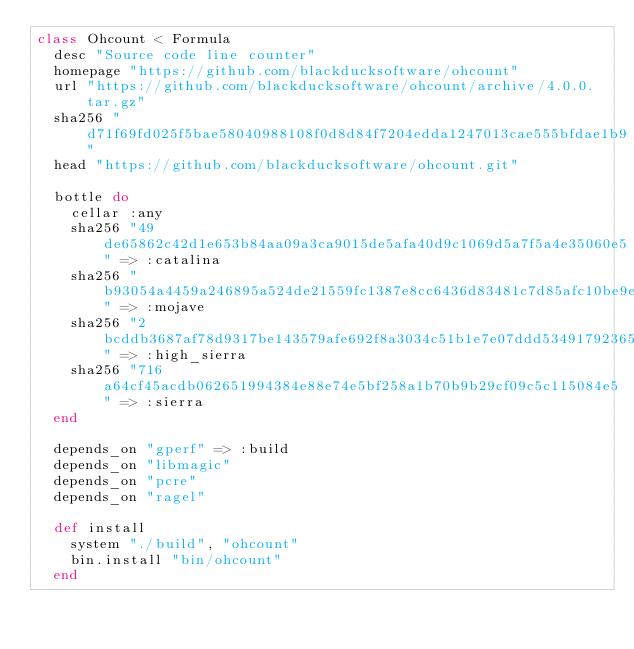<code> <loc_0><loc_0><loc_500><loc_500><_Ruby_>class Ohcount < Formula
  desc "Source code line counter"
  homepage "https://github.com/blackducksoftware/ohcount"
  url "https://github.com/blackducksoftware/ohcount/archive/4.0.0.tar.gz"
  sha256 "d71f69fd025f5bae58040988108f0d8d84f7204edda1247013cae555bfdae1b9"
  head "https://github.com/blackducksoftware/ohcount.git"

  bottle do
    cellar :any
    sha256 "49de65862c42d1e653b84aa09a3ca9015de5afa40d9c1069d5a7f5a4e35060e5" => :catalina
    sha256 "b93054a4459a246895a524de21559fc1387e8cc6436d83481c7d85afc10be9e8" => :mojave
    sha256 "2bcddb3687af78d9317be143579afe692f8a3034c51b1e7e07ddd53491792365" => :high_sierra
    sha256 "716a64cf45acdb062651994384e88e74e5bf258a1b70b9b29cf09c5c115084e5" => :sierra
  end

  depends_on "gperf" => :build
  depends_on "libmagic"
  depends_on "pcre"
  depends_on "ragel"

  def install
    system "./build", "ohcount"
    bin.install "bin/ohcount"
  end
</code> 